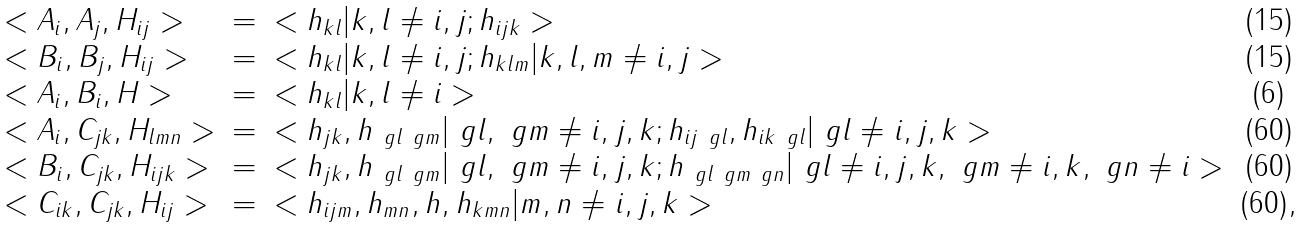Convert formula to latex. <formula><loc_0><loc_0><loc_500><loc_500>\begin{array} { l c l c } < A _ { i } , A _ { j } , H _ { i j } > & = & < h _ { k l } | k , l \neq i , j ; h _ { i j k } > & ( 1 5 ) \\ < B _ { i } , B _ { j } , H _ { i j } > & = & < h _ { k l } | k , l \neq i , j ; h _ { k l m } | k , l , m \neq i , j > & ( 1 5 ) \\ < A _ { i } , B _ { i } , H > & = & < h _ { k l } | k , l \neq i > & ( 6 ) \\ < A _ { i } , C _ { j k } , H _ { l m n } > & = & < h _ { j k } , h _ { \ g l \ g m } | \ g l , \ g m \neq i , j , k ; h _ { i j \ g l } , h _ { i k \ g l } | \ g l \neq i , j , k > & ( 6 0 ) \\ < B _ { i } , C _ { j k } , H _ { i j k } > & = & < h _ { j k } , h _ { \ g l \ g m } | \ g l , \ g m \neq i , j , k ; h _ { \ g l \ g m \ g n } | \ g l \neq i , j , k , \ g m \neq i , k , \ g n \neq i > & ( 6 0 ) \\ < C _ { i k } , C _ { j k } , H _ { i j } > & = & < h _ { i j m } , h _ { m n } , h , h _ { k m n } | m , n \neq i , j , k > & ( 6 0 ) , \\ \end{array}</formula> 